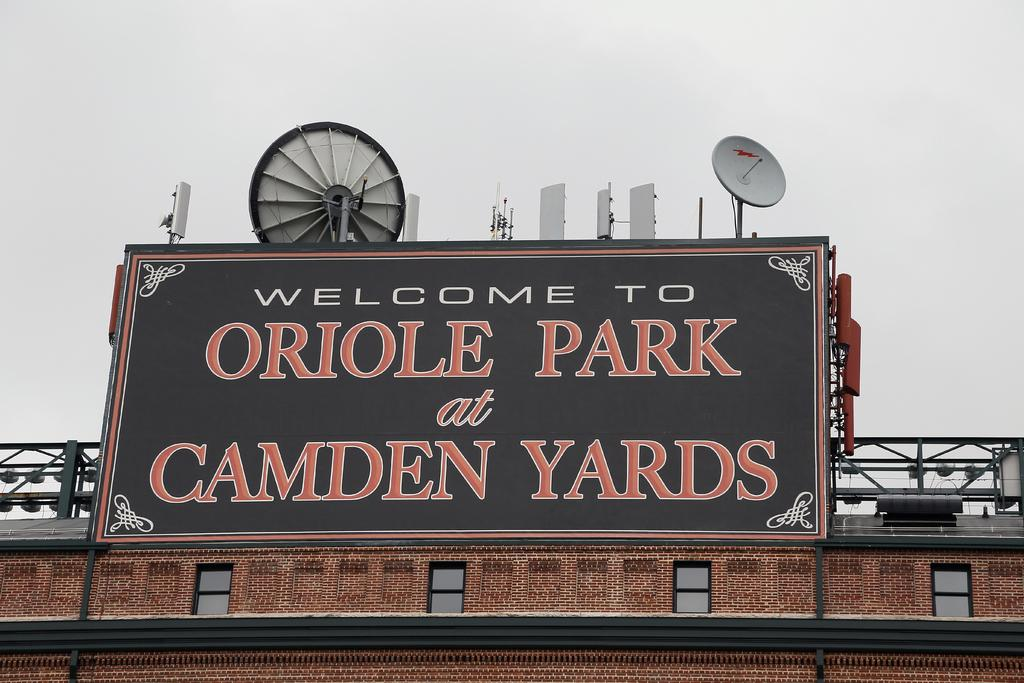What type of structure is present in the image? There is a building in the image. What additional objects can be seen on the building? There are satellite dishes in the image. Is there any text or information displayed on the building? Yes, there is a board with writing on it in the image. What can be seen in the background of the image? The sky is visible in the background of the image. How many times does the chalk twist while writing on the board in the image? There is no chalk present in the image, and therefore no writing is being done with chalk. 